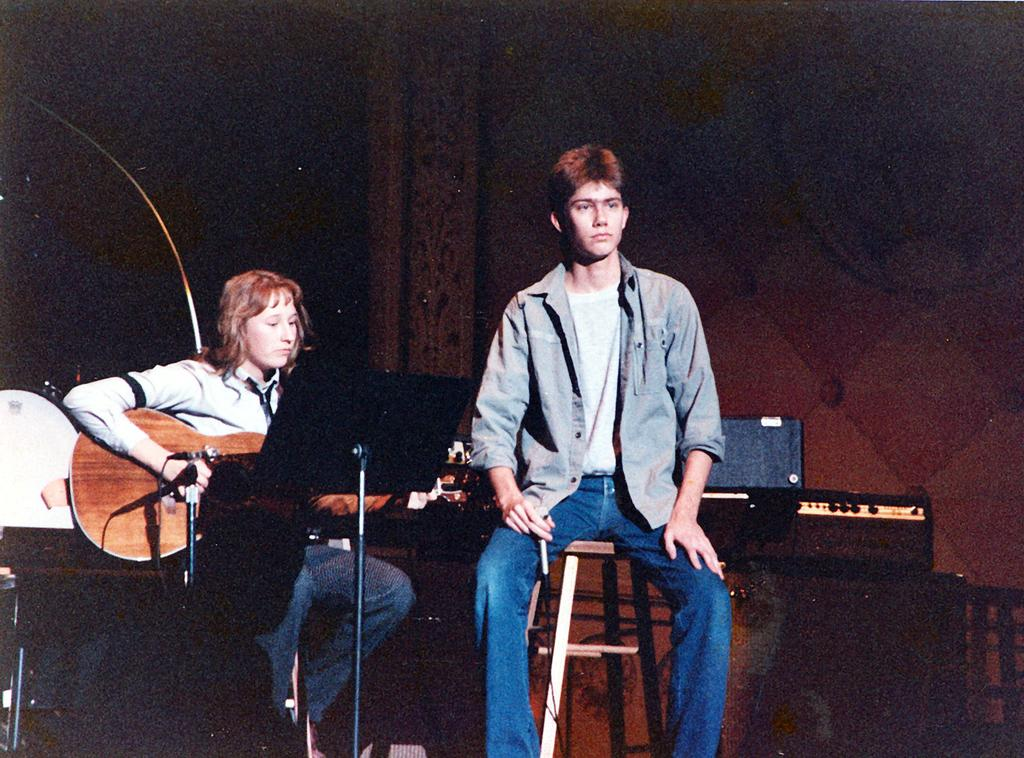What is the man in the image doing? The man is sitting in a chair in the image. What is the woman in the image doing? The woman is sitting and playing a guitar in the image. What can be seen in the background of the image? There is a wall, drums, and briefcases in the background of the image. What type of ray is visible in the image? There is no ray present in the image. What is the relation between the man and the woman in the image? The provided facts do not give any information about the relationship between the man and the woman in the image. --- Facts: 1. There is a car in the image. 2. The car is parked on the street. 3. There are trees on the street. 4. There is a sidewalk in the image. 5. There are people walking on the sidewalk. Absurd Topics: fish, ocean, waves Conversation: What is the main subject of the image? The main subject of the image is a car. Where is the car located in the image? The car is parked on the street in the image. What can be seen on the street besides the car? There are trees on the street in the image. What type of path is visible in the image? There is a sidewalk in the image. What are the people on the sidewalk doing? There are people walking on the sidewalk in the image. Reasoning: Let's think step by step in order to produce the conversation. We start by identifying the main subject of the image, which is the car. Then, we describe the location of the car, noting that it is parked on the street. Next, we mention the presence of trees on the street and a sidewalk in the image. Finally, we observe the actions of the people on the sidewalk, noting that they are walking. Each question is designed to elicit a specific detail about the image that is known from the provided facts. Absurd Question/Answer: Can you see any fish swimming in the ocean in the image? There is no ocean or fish present in the image. What type of waves can be seen in the image? There are no waves present in the image. 